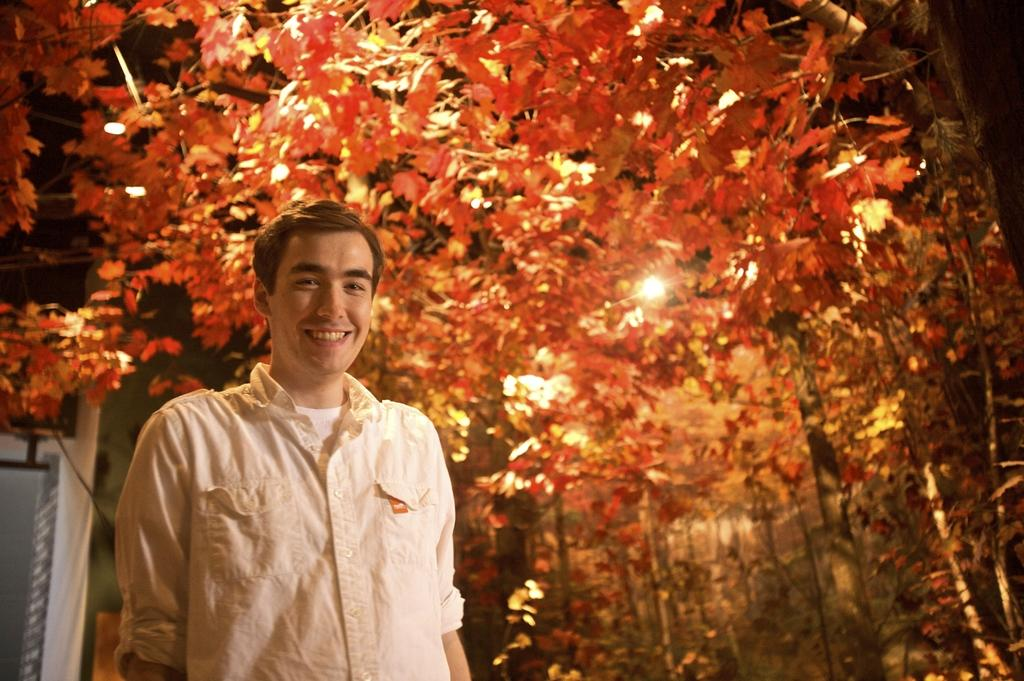What is the main subject of the image? There is a person standing in the center of the image. What is the person's expression in the image? The person is smiling. What can be seen in the background of the image? There are trees, a pole, and a light in the background of the image. What type of test is the person taking in the image? There is no test present in the image; it features a person standing and smiling. What type of ground is visible in the image? The ground is not visible in the image; it only shows a person standing, trees, a pole, and a light in the background. 